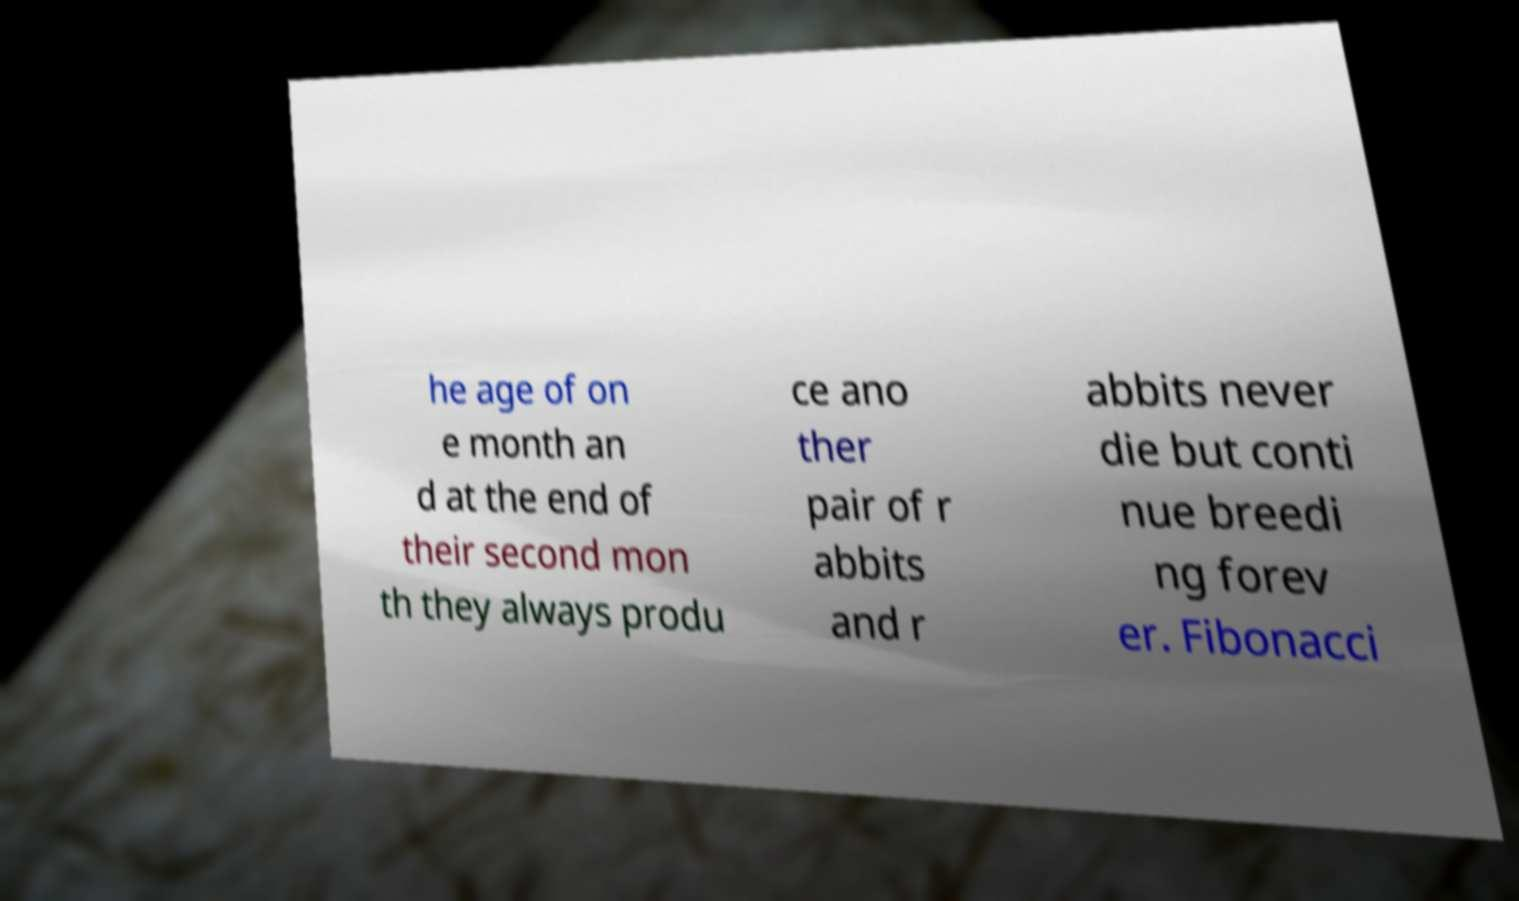Can you read and provide the text displayed in the image?This photo seems to have some interesting text. Can you extract and type it out for me? he age of on e month an d at the end of their second mon th they always produ ce ano ther pair of r abbits and r abbits never die but conti nue breedi ng forev er. Fibonacci 